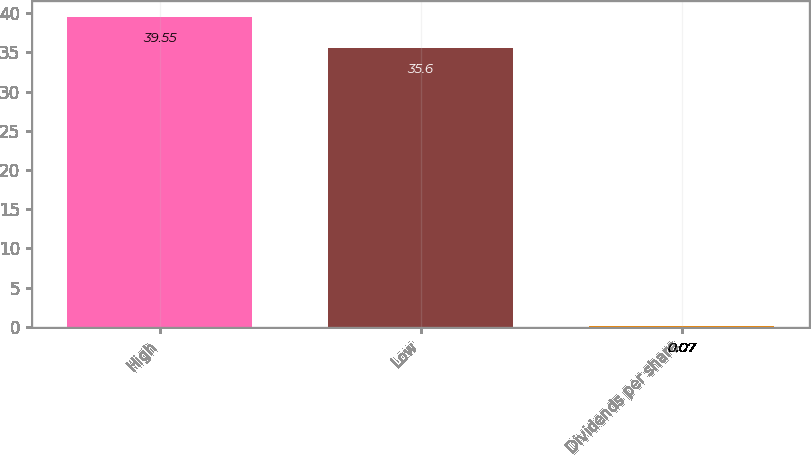Convert chart. <chart><loc_0><loc_0><loc_500><loc_500><bar_chart><fcel>High<fcel>Low<fcel>Dividends per share<nl><fcel>39.55<fcel>35.6<fcel>0.07<nl></chart> 